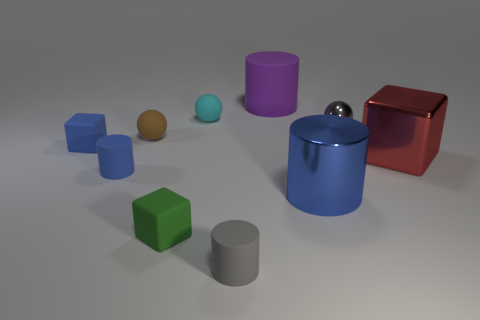Subtract all rubber cylinders. How many cylinders are left? 1 Subtract 3 cylinders. How many cylinders are left? 1 Subtract all green blocks. How many blocks are left? 2 Subtract all yellow cylinders. How many brown spheres are left? 1 Subtract all purple cylinders. Subtract all big blue metal cylinders. How many objects are left? 8 Add 8 big red blocks. How many big red blocks are left? 9 Add 9 small blue cylinders. How many small blue cylinders exist? 10 Subtract 0 yellow spheres. How many objects are left? 10 Subtract all balls. How many objects are left? 7 Subtract all purple cubes. Subtract all gray cylinders. How many cubes are left? 3 